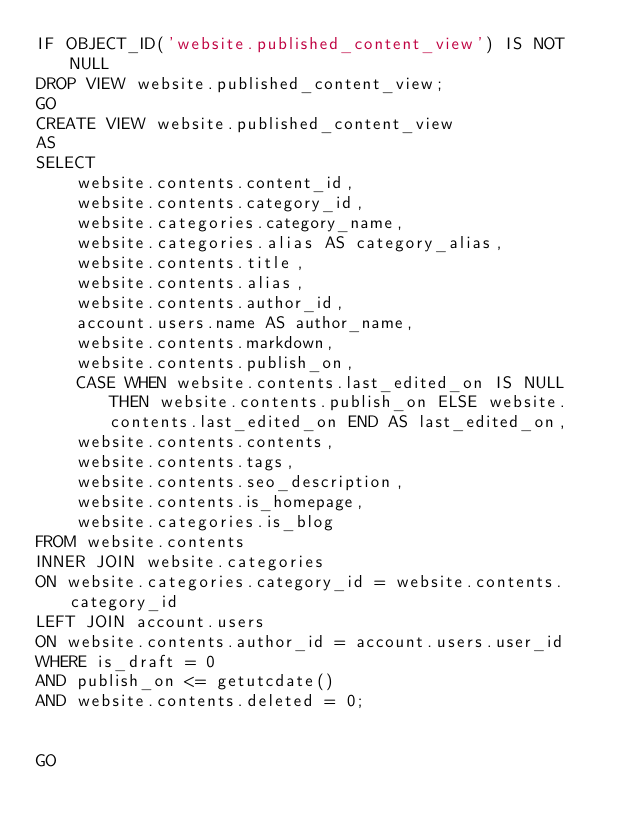Convert code to text. <code><loc_0><loc_0><loc_500><loc_500><_SQL_>IF OBJECT_ID('website.published_content_view') IS NOT NULL
DROP VIEW website.published_content_view;
GO
CREATE VIEW website.published_content_view
AS
SELECT
    website.contents.content_id,
    website.contents.category_id,
    website.categories.category_name,
    website.categories.alias AS category_alias,
    website.contents.title,
    website.contents.alias,
    website.contents.author_id,
    account.users.name AS author_name,
    website.contents.markdown,
    website.contents.publish_on,
    CASE WHEN website.contents.last_edited_on IS NULL THEN website.contents.publish_on ELSE website.contents.last_edited_on END AS last_edited_on,
    website.contents.contents,
    website.contents.tags,
    website.contents.seo_description,
    website.contents.is_homepage,
    website.categories.is_blog
FROM website.contents
INNER JOIN website.categories
ON website.categories.category_id = website.contents.category_id
LEFT JOIN account.users
ON website.contents.author_id = account.users.user_id
WHERE is_draft = 0
AND publish_on <= getutcdate()
AND website.contents.deleted = 0;


GO
</code> 